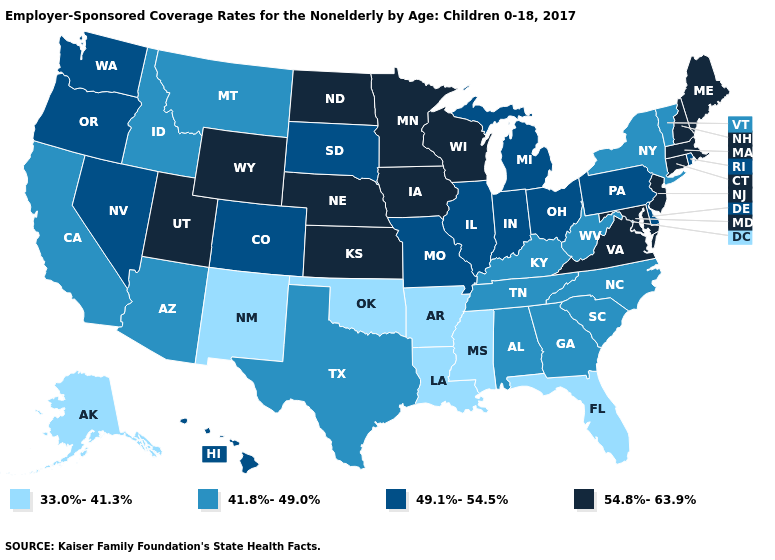What is the lowest value in the USA?
Concise answer only. 33.0%-41.3%. Does Iowa have the lowest value in the MidWest?
Give a very brief answer. No. Name the states that have a value in the range 49.1%-54.5%?
Short answer required. Colorado, Delaware, Hawaii, Illinois, Indiana, Michigan, Missouri, Nevada, Ohio, Oregon, Pennsylvania, Rhode Island, South Dakota, Washington. Among the states that border Oregon , does California have the highest value?
Answer briefly. No. Does Illinois have a lower value than New Hampshire?
Be succinct. Yes. What is the lowest value in the USA?
Quick response, please. 33.0%-41.3%. Does the map have missing data?
Quick response, please. No. What is the value of Kentucky?
Give a very brief answer. 41.8%-49.0%. What is the value of North Dakota?
Short answer required. 54.8%-63.9%. What is the lowest value in states that border Minnesota?
Be succinct. 49.1%-54.5%. Name the states that have a value in the range 54.8%-63.9%?
Be succinct. Connecticut, Iowa, Kansas, Maine, Maryland, Massachusetts, Minnesota, Nebraska, New Hampshire, New Jersey, North Dakota, Utah, Virginia, Wisconsin, Wyoming. Name the states that have a value in the range 54.8%-63.9%?
Write a very short answer. Connecticut, Iowa, Kansas, Maine, Maryland, Massachusetts, Minnesota, Nebraska, New Hampshire, New Jersey, North Dakota, Utah, Virginia, Wisconsin, Wyoming. Name the states that have a value in the range 41.8%-49.0%?
Keep it brief. Alabama, Arizona, California, Georgia, Idaho, Kentucky, Montana, New York, North Carolina, South Carolina, Tennessee, Texas, Vermont, West Virginia. How many symbols are there in the legend?
Short answer required. 4. Name the states that have a value in the range 49.1%-54.5%?
Quick response, please. Colorado, Delaware, Hawaii, Illinois, Indiana, Michigan, Missouri, Nevada, Ohio, Oregon, Pennsylvania, Rhode Island, South Dakota, Washington. 